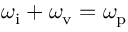<formula> <loc_0><loc_0><loc_500><loc_500>\omega _ { i } + \omega _ { v } = \omega _ { p }</formula> 